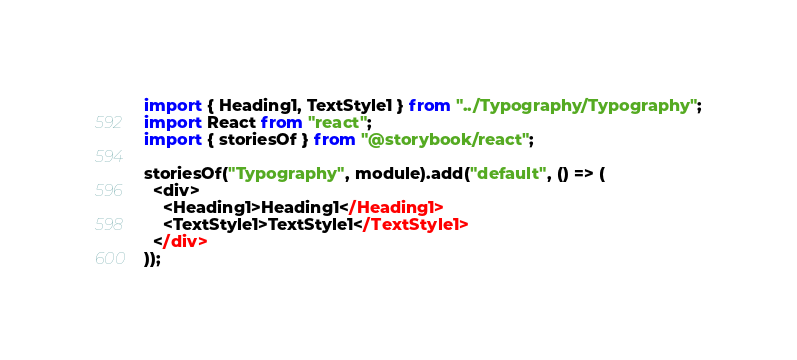Convert code to text. <code><loc_0><loc_0><loc_500><loc_500><_JavaScript_>import { Heading1, TextStyle1 } from "../Typography/Typography";
import React from "react";
import { storiesOf } from "@storybook/react";

storiesOf("Typography", module).add("default", () => (
  <div>
    <Heading1>Heading1</Heading1>
    <TextStyle1>TextStyle1</TextStyle1>
  </div>
));
</code> 